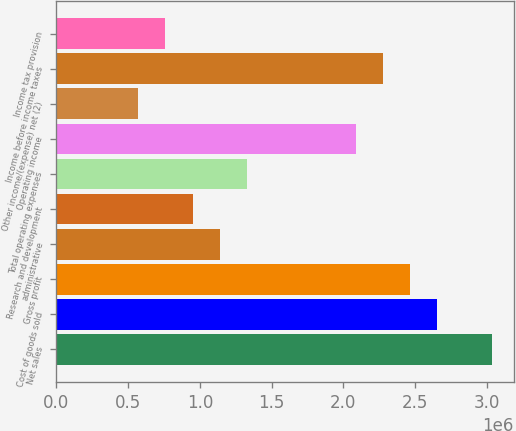Convert chart to OTSL. <chart><loc_0><loc_0><loc_500><loc_500><bar_chart><fcel>Net sales<fcel>Cost of goods sold<fcel>Gross profit<fcel>administrative<fcel>Research and development<fcel>Total operating expenses<fcel>Operating income<fcel>Other income/(expense) net (2)<fcel>Income before income taxes<fcel>Income tax provision<nl><fcel>3.03523e+06<fcel>2.65583e+06<fcel>2.46613e+06<fcel>1.13821e+06<fcel>948510<fcel>1.32791e+06<fcel>2.08672e+06<fcel>569106<fcel>2.27642e+06<fcel>758808<nl></chart> 